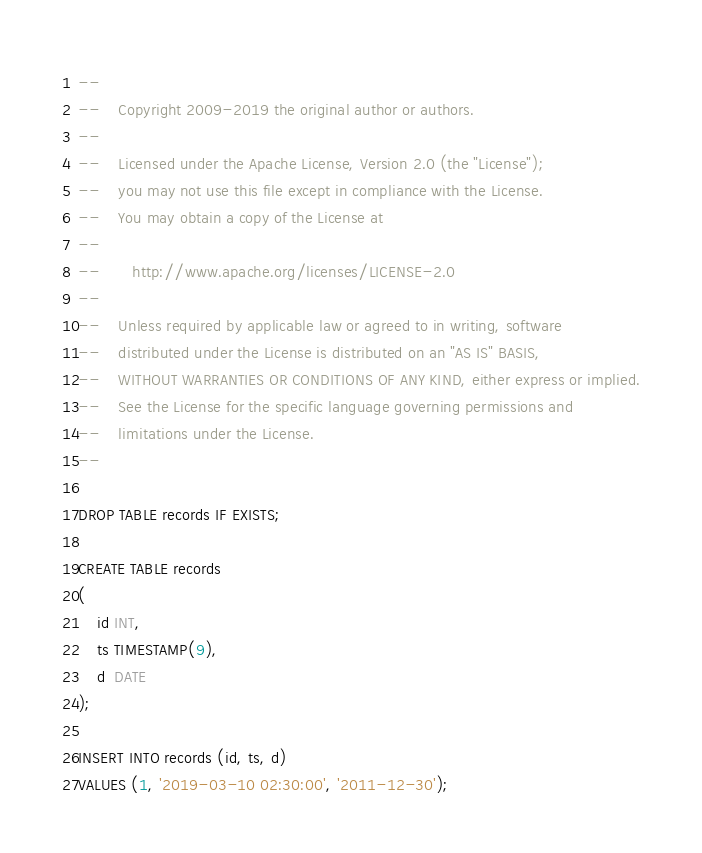<code> <loc_0><loc_0><loc_500><loc_500><_SQL_>--
--    Copyright 2009-2019 the original author or authors.
--
--    Licensed under the Apache License, Version 2.0 (the "License");
--    you may not use this file except in compliance with the License.
--    You may obtain a copy of the License at
--
--       http://www.apache.org/licenses/LICENSE-2.0
--
--    Unless required by applicable law or agreed to in writing, software
--    distributed under the License is distributed on an "AS IS" BASIS,
--    WITHOUT WARRANTIES OR CONDITIONS OF ANY KIND, either express or implied.
--    See the License for the specific language governing permissions and
--    limitations under the License.
--

DROP TABLE records IF EXISTS;

CREATE TABLE records
(
    id INT,
    ts TIMESTAMP(9),
    d  DATE
);

INSERT INTO records (id, ts, d)
VALUES (1, '2019-03-10 02:30:00', '2011-12-30');
</code> 